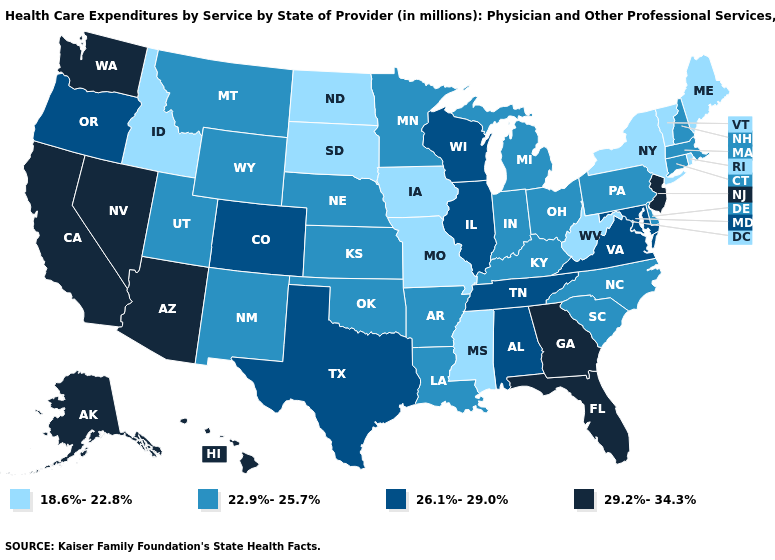Name the states that have a value in the range 22.9%-25.7%?
Short answer required. Arkansas, Connecticut, Delaware, Indiana, Kansas, Kentucky, Louisiana, Massachusetts, Michigan, Minnesota, Montana, Nebraska, New Hampshire, New Mexico, North Carolina, Ohio, Oklahoma, Pennsylvania, South Carolina, Utah, Wyoming. What is the highest value in the West ?
Give a very brief answer. 29.2%-34.3%. What is the highest value in the MidWest ?
Write a very short answer. 26.1%-29.0%. Is the legend a continuous bar?
Write a very short answer. No. What is the value of Oklahoma?
Concise answer only. 22.9%-25.7%. What is the value of Maine?
Answer briefly. 18.6%-22.8%. Name the states that have a value in the range 18.6%-22.8%?
Write a very short answer. Idaho, Iowa, Maine, Mississippi, Missouri, New York, North Dakota, Rhode Island, South Dakota, Vermont, West Virginia. What is the lowest value in the South?
Answer briefly. 18.6%-22.8%. Does the map have missing data?
Write a very short answer. No. Which states have the lowest value in the Northeast?
Write a very short answer. Maine, New York, Rhode Island, Vermont. What is the lowest value in the West?
Short answer required. 18.6%-22.8%. What is the lowest value in states that border Idaho?
Be succinct. 22.9%-25.7%. Among the states that border South Carolina , does North Carolina have the highest value?
Give a very brief answer. No. Name the states that have a value in the range 22.9%-25.7%?
Concise answer only. Arkansas, Connecticut, Delaware, Indiana, Kansas, Kentucky, Louisiana, Massachusetts, Michigan, Minnesota, Montana, Nebraska, New Hampshire, New Mexico, North Carolina, Ohio, Oklahoma, Pennsylvania, South Carolina, Utah, Wyoming. What is the value of Colorado?
Concise answer only. 26.1%-29.0%. 